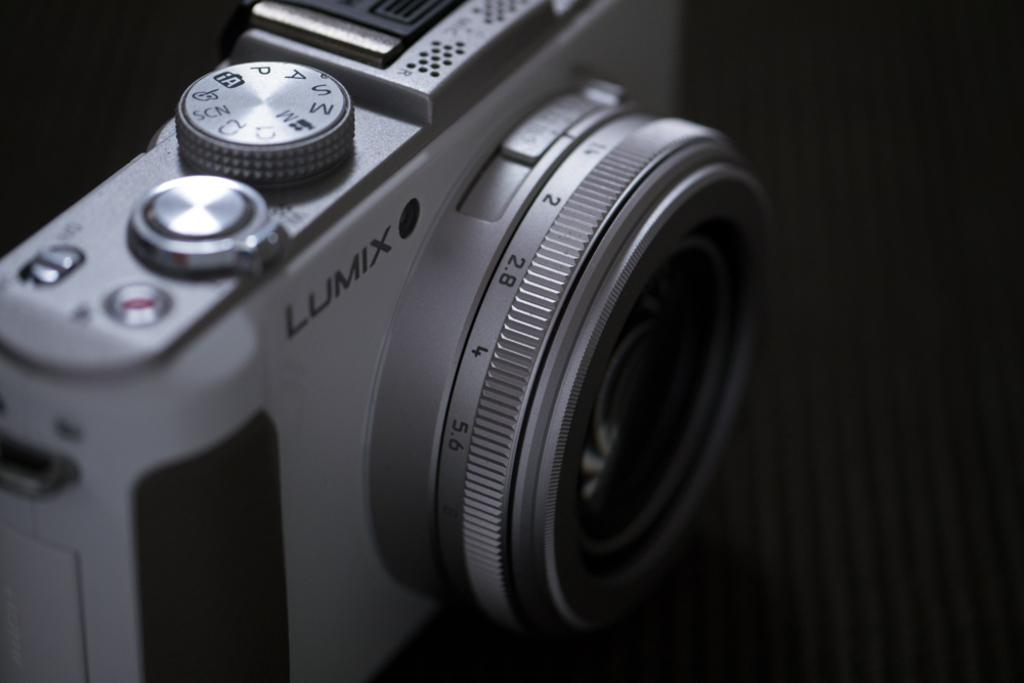What object is located on the left side of the image? There is a camera on the left side of the image. What can be seen on the camera itself? There is text and numbers on the camera. How would you describe the background of the image? The background of the image is dark. What type of weather can be seen in the image? There is no weather visible in the image, as it is focused on the camera and its surroundings. 